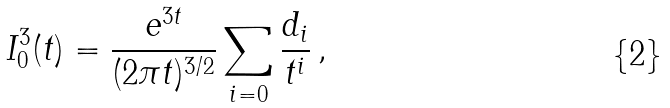<formula> <loc_0><loc_0><loc_500><loc_500>I _ { 0 } ^ { 3 } ( t ) = \frac { e ^ { 3 t } } { ( 2 \pi t ) ^ { 3 / 2 } } \sum _ { i = 0 } \frac { d _ { i } } { t ^ { i } } \, ,</formula> 